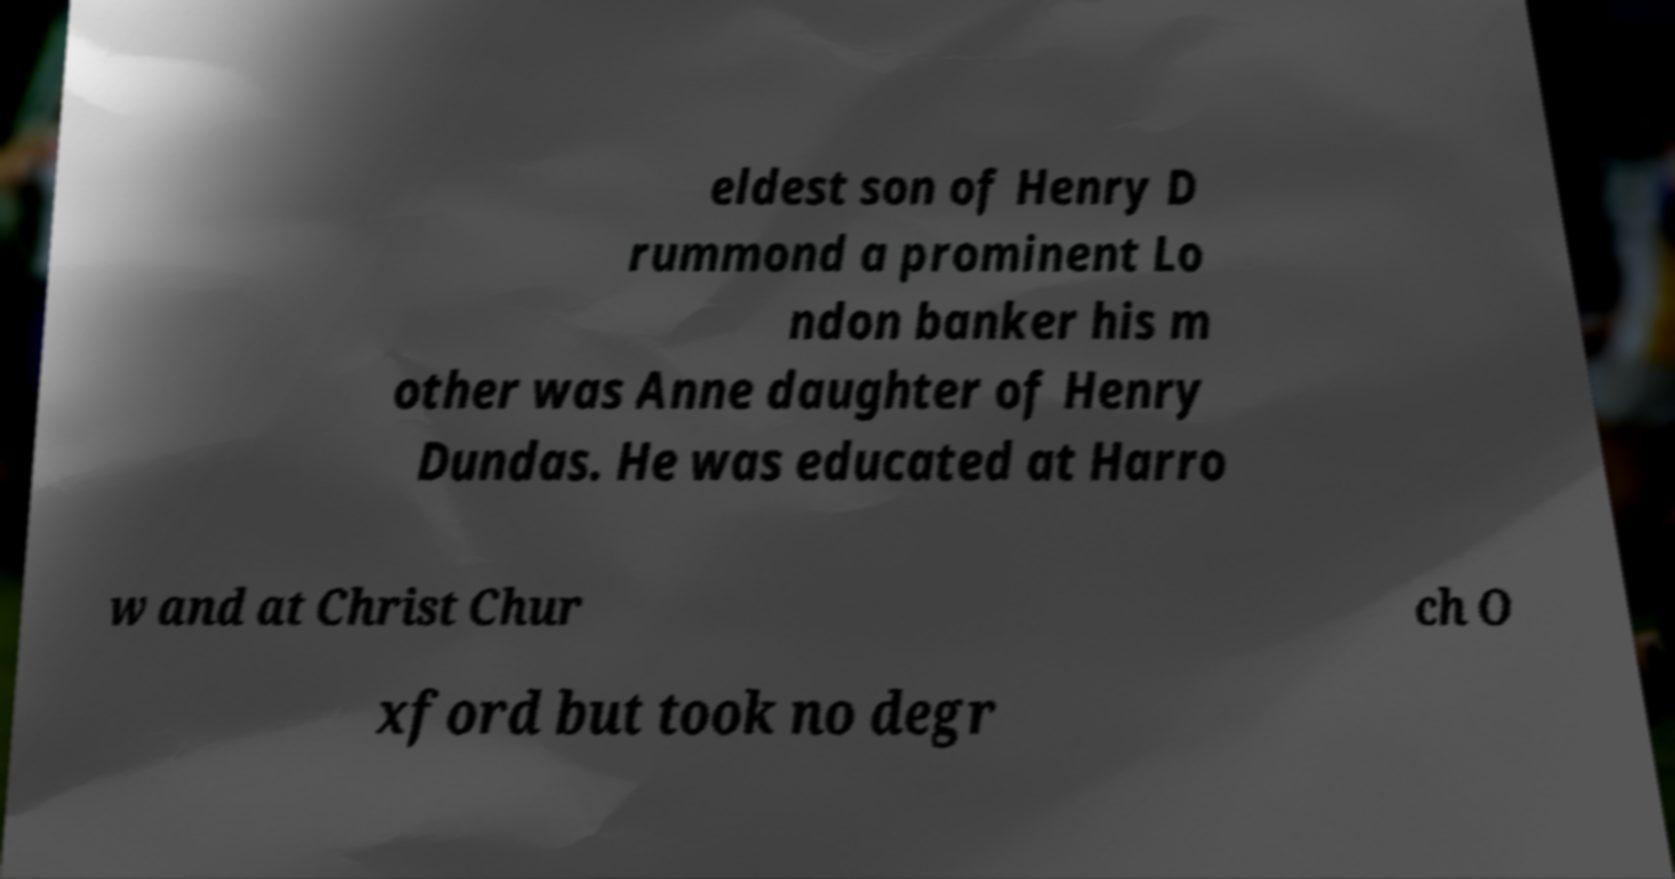I need the written content from this picture converted into text. Can you do that? eldest son of Henry D rummond a prominent Lo ndon banker his m other was Anne daughter of Henry Dundas. He was educated at Harro w and at Christ Chur ch O xford but took no degr 